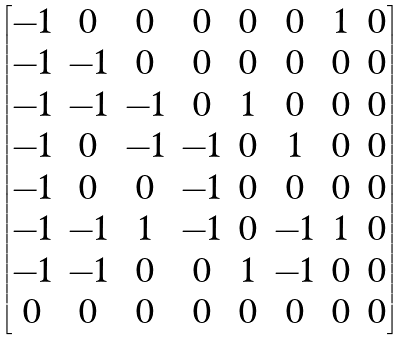<formula> <loc_0><loc_0><loc_500><loc_500>\begin{bmatrix} - 1 & 0 & 0 & 0 & 0 & 0 & 1 & 0 \\ - 1 & - 1 & 0 & 0 & 0 & 0 & 0 & 0 \\ - 1 & - 1 & - 1 & 0 & 1 & 0 & 0 & 0 \\ - 1 & 0 & - 1 & - 1 & 0 & 1 & 0 & 0 \\ - 1 & 0 & 0 & - 1 & 0 & 0 & 0 & 0 \\ - 1 & - 1 & 1 & - 1 & 0 & - 1 & 1 & 0 \\ - 1 & - 1 & 0 & 0 & 1 & - 1 & 0 & 0 \\ 0 & 0 & 0 & 0 & 0 & 0 & 0 & 0 \\ \end{bmatrix}</formula> 